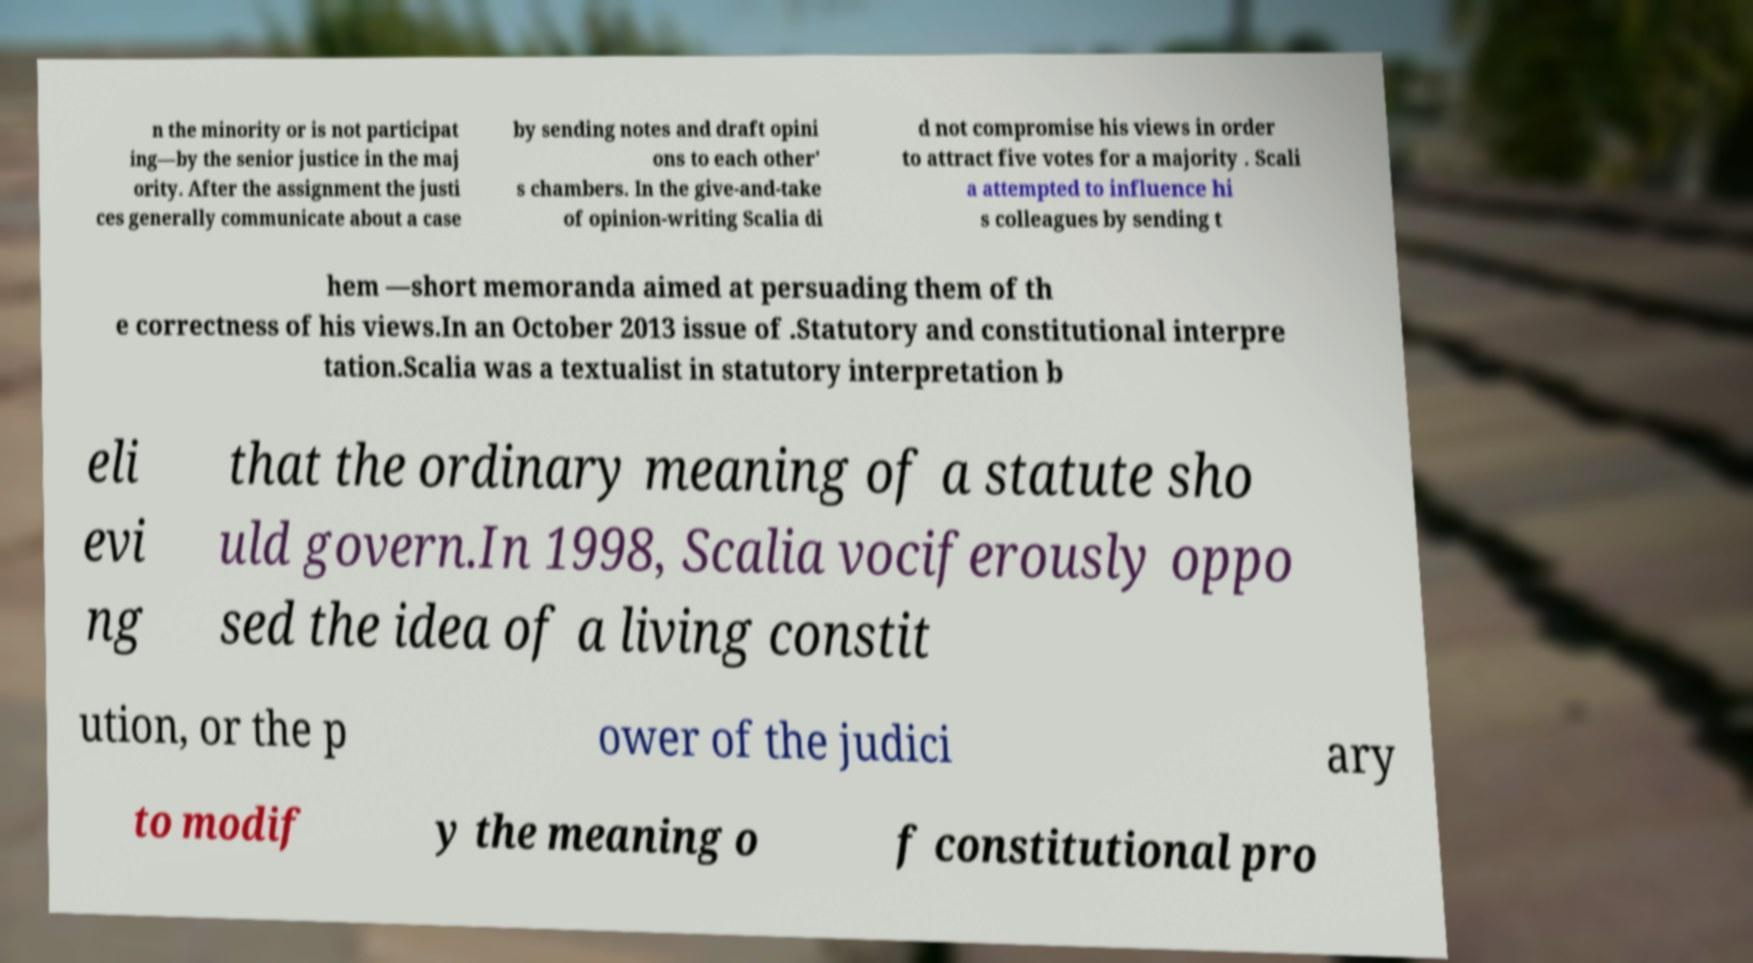There's text embedded in this image that I need extracted. Can you transcribe it verbatim? n the minority or is not participat ing—by the senior justice in the maj ority. After the assignment the justi ces generally communicate about a case by sending notes and draft opini ons to each other' s chambers. In the give-and-take of opinion-writing Scalia di d not compromise his views in order to attract five votes for a majority . Scali a attempted to influence hi s colleagues by sending t hem —short memoranda aimed at persuading them of th e correctness of his views.In an October 2013 issue of .Statutory and constitutional interpre tation.Scalia was a textualist in statutory interpretation b eli evi ng that the ordinary meaning of a statute sho uld govern.In 1998, Scalia vociferously oppo sed the idea of a living constit ution, or the p ower of the judici ary to modif y the meaning o f constitutional pro 